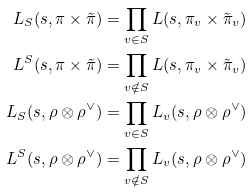<formula> <loc_0><loc_0><loc_500><loc_500>L _ { S } ( s , \pi \times \tilde { \pi } ) & = \prod _ { v \in S } L ( s , \pi _ { v } \times \tilde { \pi } _ { v } ) \\ L ^ { S } ( s , \pi \times \tilde { \pi } ) & = \prod _ { v \notin S } L ( s , \pi _ { v } \times \tilde { \pi } _ { v } ) \\ L _ { S } ( s , \rho \otimes \rho ^ { \vee } ) & = \prod _ { v \in S } L _ { v } ( s , \rho \otimes \rho ^ { \vee } ) \\ L ^ { S } ( s , \rho \otimes \rho ^ { \vee } ) & = \prod _ { v \notin S } L _ { v } ( s , \rho \otimes \rho ^ { \vee } )</formula> 